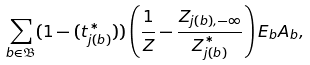Convert formula to latex. <formula><loc_0><loc_0><loc_500><loc_500>\sum _ { b \in \mathfrak B } ( 1 - ( t ^ { * } _ { j ( b ) } ) ) \left ( \frac { 1 } { Z } - \frac { Z _ { j ( b ) , - \infty } } { Z ^ { * } _ { j ( b ) } } \right ) E _ { b } A _ { b } ,</formula> 